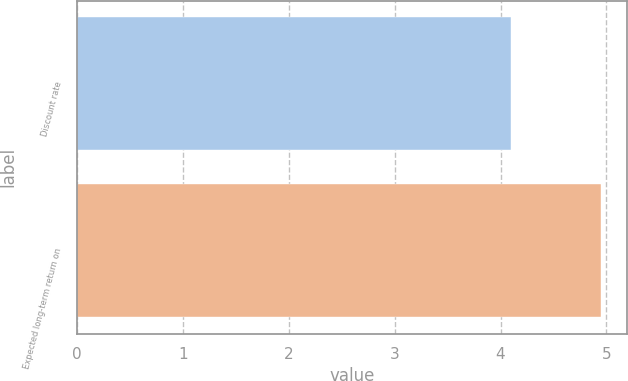Convert chart to OTSL. <chart><loc_0><loc_0><loc_500><loc_500><bar_chart><fcel>Discount rate<fcel>Expected long-term return on<nl><fcel>4.1<fcel>4.95<nl></chart> 